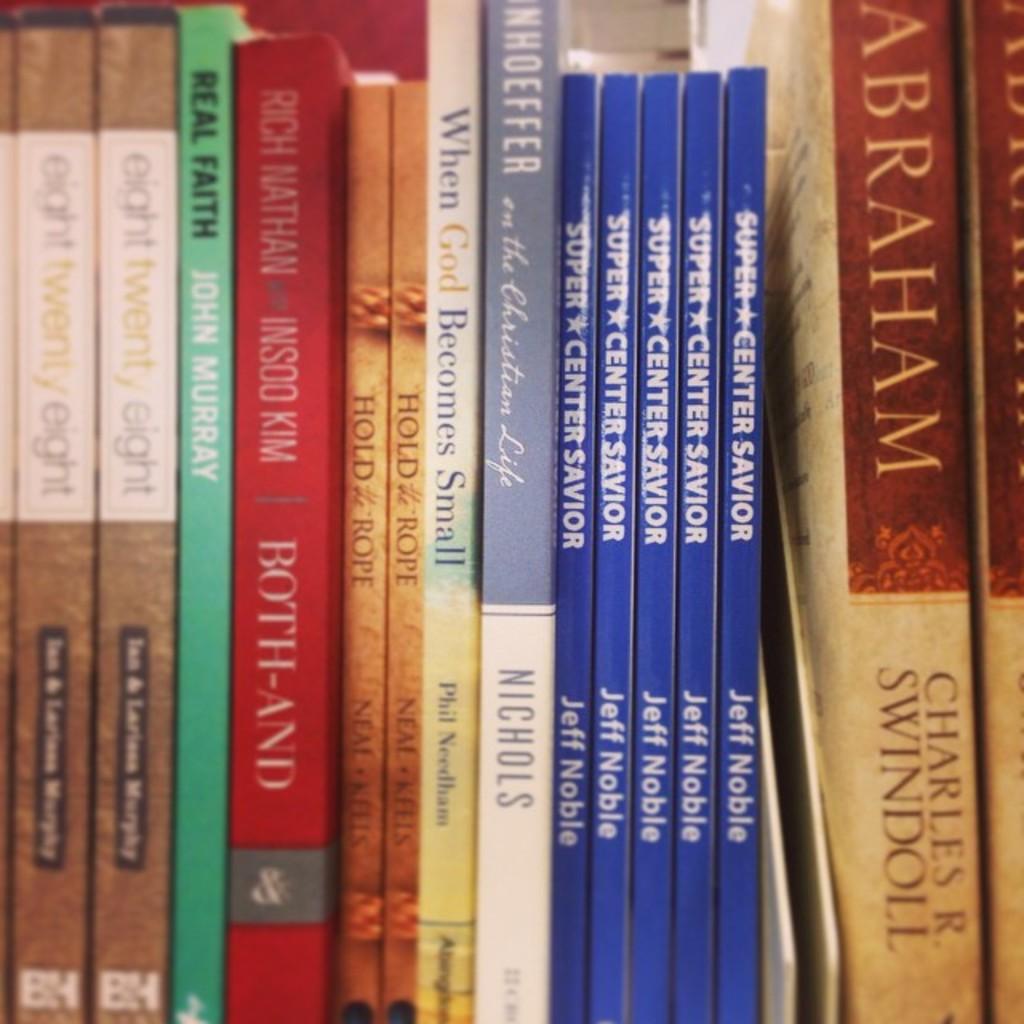Who is the author of the green book?
Give a very brief answer. John murray. Who is the author of the book on the left?
Provide a succinct answer. Unanswerable. 